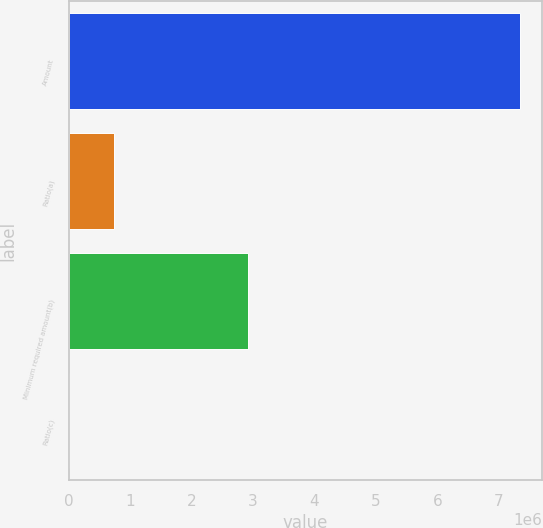<chart> <loc_0><loc_0><loc_500><loc_500><bar_chart><fcel>Amount<fcel>Ratio(a)<fcel>Minimum required amount(b)<fcel>Ratio(c)<nl><fcel>7.34151e+06<fcel>734159<fcel>2.91425e+06<fcel>9.09<nl></chart> 